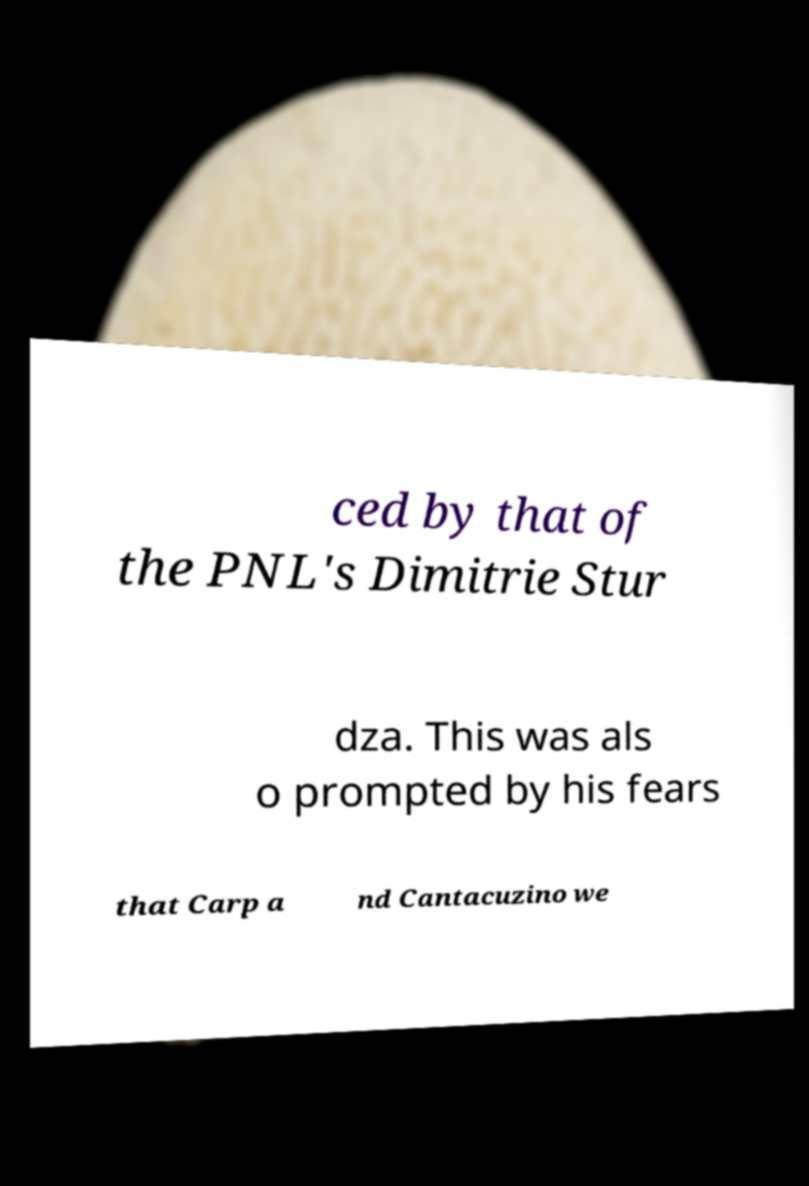Please identify and transcribe the text found in this image. ced by that of the PNL's Dimitrie Stur dza. This was als o prompted by his fears that Carp a nd Cantacuzino we 